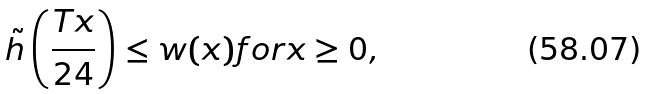<formula> <loc_0><loc_0><loc_500><loc_500>\tilde { h } \left ( \frac { T x } { 2 4 } \right ) \leq w ( x ) f o r x \geq 0 ,</formula> 